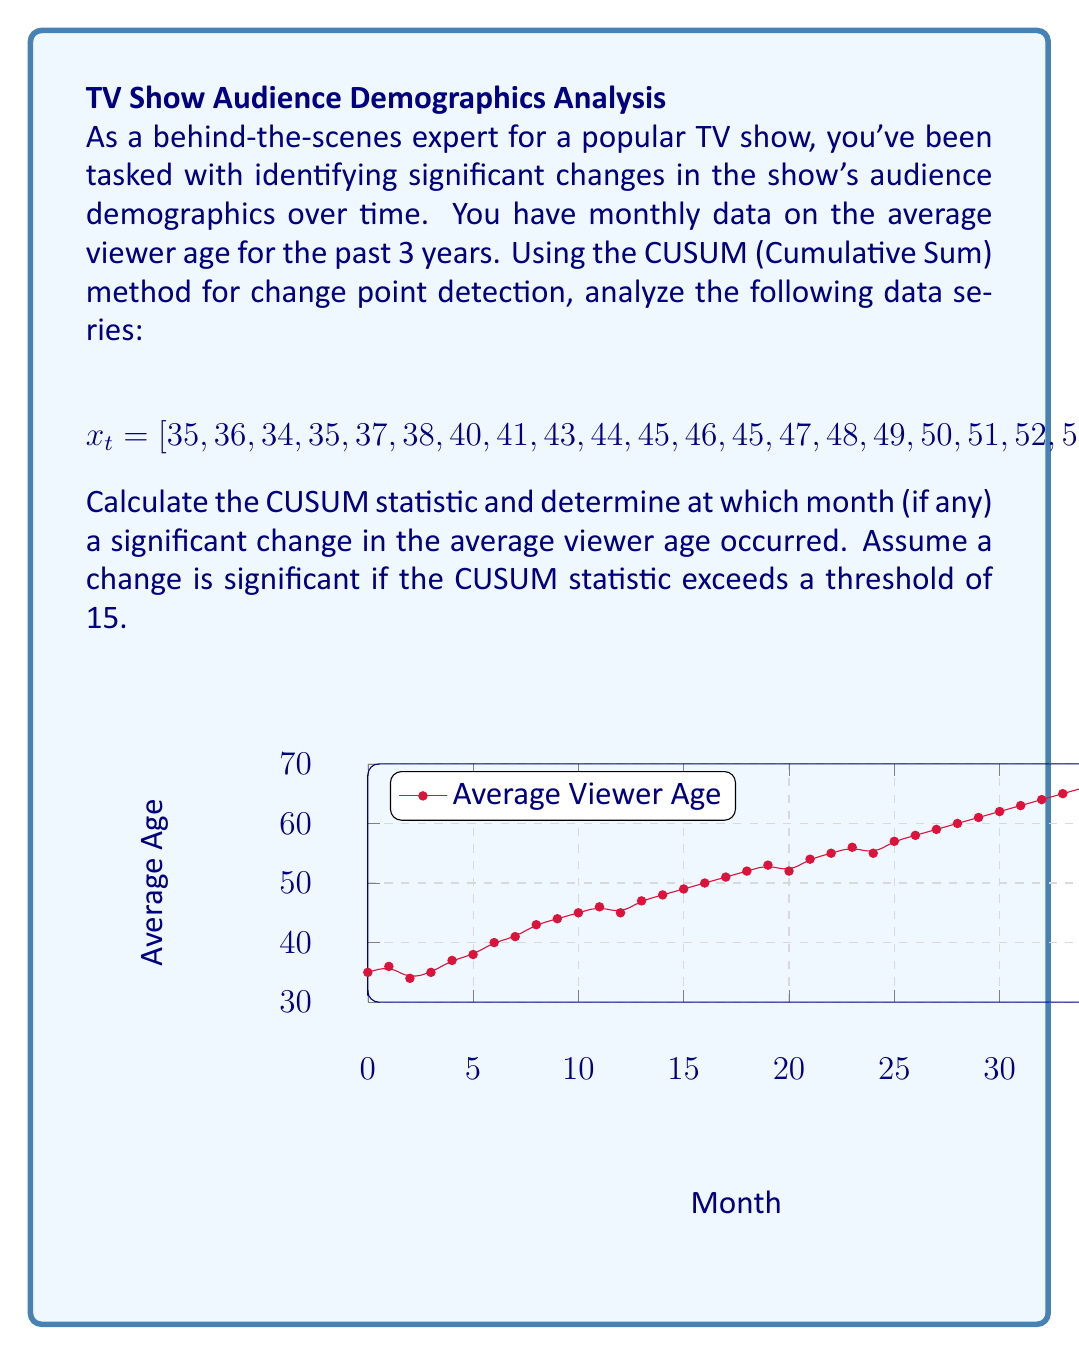Can you solve this math problem? To solve this problem using the CUSUM method, we'll follow these steps:

1) Calculate the mean of the entire series:
   $$\mu = \frac{1}{36}\sum_{i=1}^{36} x_i = 50$$

2) Calculate the CUSUM statistic for each point:
   $$S_t = \sum_{i=1}^{t} (x_i - \mu)$$

3) Find the maximum absolute CUSUM value:
   $$S_{max} = \max_{1\leq t\leq 36} |S_t|$$

4) Determine if a change point occurred by comparing $S_{max}$ to the threshold.

Let's calculate the CUSUM values:

$S_1 = 35 - 50 = -15$
$S_2 = (35 - 50) + (36 - 50) = -29$
$S_3 = -29 + (34 - 50) = -45$
...

Continuing this process, we get:

$S_{12} = -126$
$S_{13} = -131$
$S_{14} = -134$
$S_{15} = -136$
$S_{16} = -137$
$S_{17} = -137$
$S_{18} = -136$
...
$S_{36} = 0$

The maximum absolute CUSUM value is:
$$S_{max} = |-137| = 137$$

Since 137 > 15 (our threshold), a significant change point has occurred.

To find when the change occurred, we look for the time t where $|S_t|$ is maximum. This occurs at t = 17, corresponding to the 17th month.
Answer: Month 17 